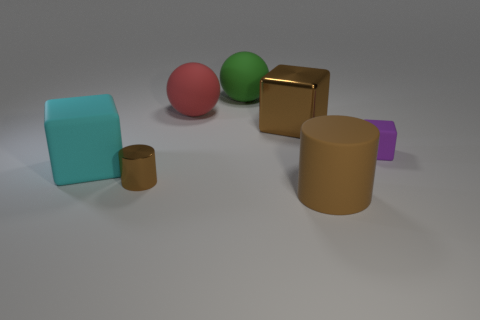There is a thing that is both in front of the cyan matte thing and on the right side of the big shiny block; what shape is it?
Your response must be concise. Cylinder. There is a brown cylinder that is in front of the metallic cylinder; how big is it?
Offer a very short reply. Large. Is the color of the tiny thing to the left of the large brown metal block the same as the large metal block?
Offer a terse response. Yes. How many large green objects are the same shape as the red matte thing?
Provide a succinct answer. 1. What number of objects are either large things in front of the large cyan matte block or brown cylinders in front of the brown metal cylinder?
Provide a succinct answer. 1. How many cyan objects are either large blocks or large rubber balls?
Keep it short and to the point. 1. What is the material of the block that is on the left side of the big brown rubber object and behind the big cyan rubber object?
Make the answer very short. Metal. Does the big red thing have the same material as the tiny brown cylinder?
Keep it short and to the point. No. How many things have the same size as the purple cube?
Your answer should be compact. 1. Are there an equal number of brown cylinders that are to the left of the large cyan matte thing and small spheres?
Offer a very short reply. Yes. 